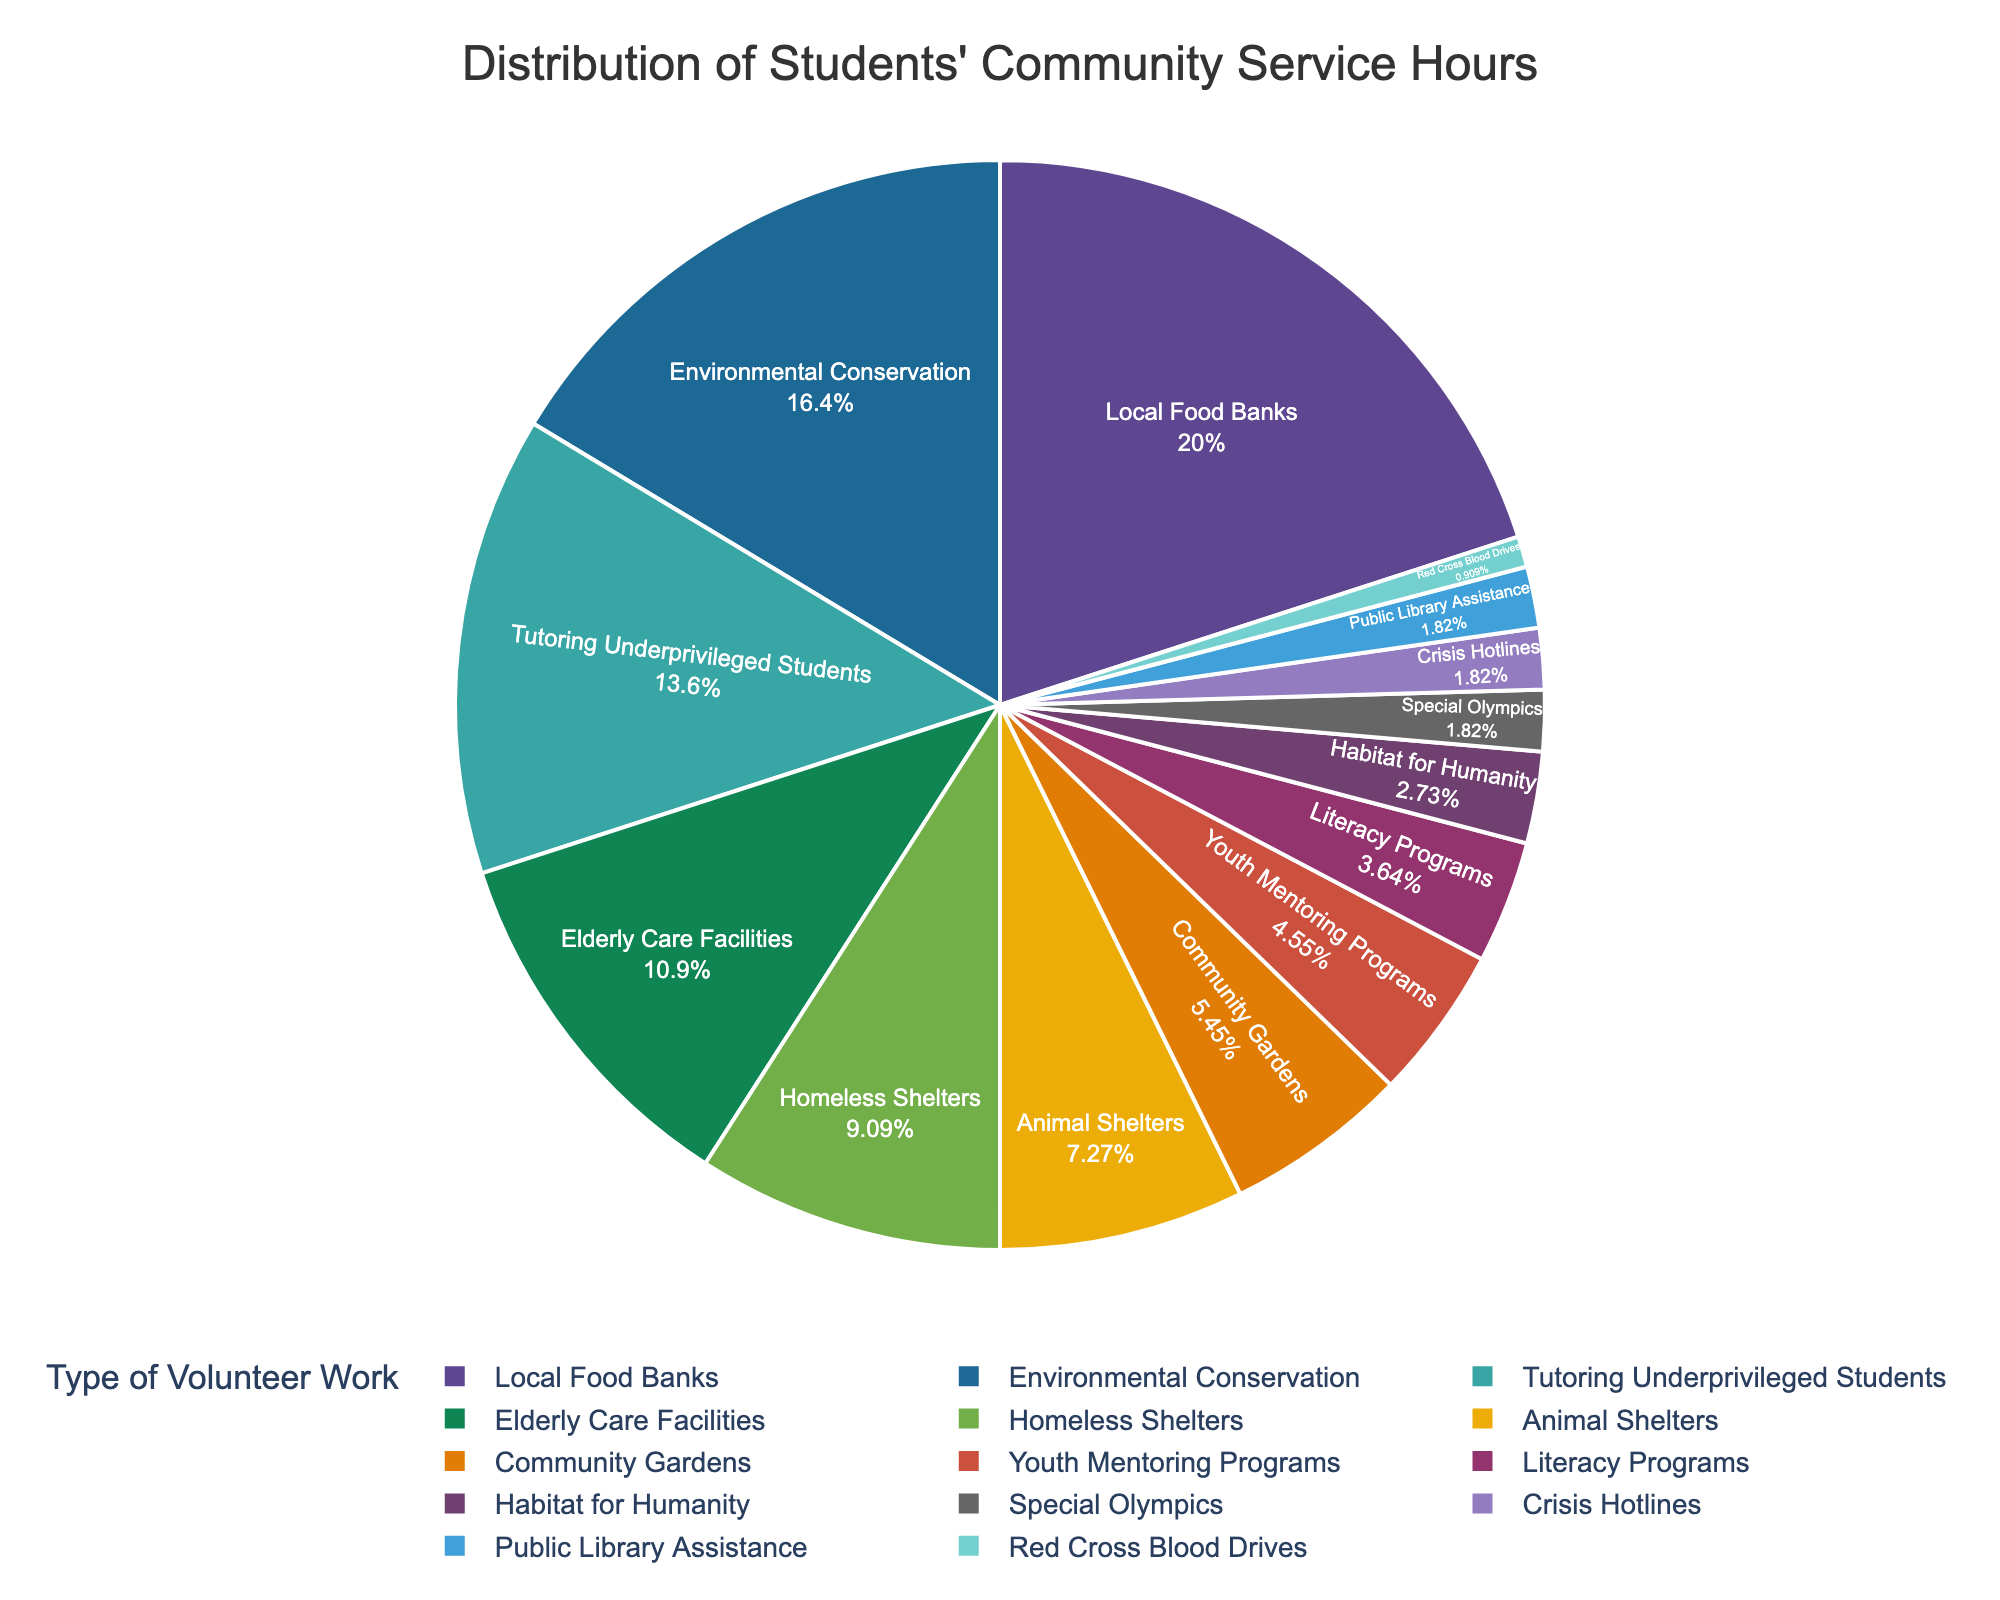Which type of volunteer work constitutes the largest percentage of students' community service hours? The slice representing "Local Food Banks" appears to be the largest one.
Answer: Local Food Banks What is the approximate percentage difference between hours spent on Environmental Conservation and Tutoring Underprivileged Students? The percentage for Environmental Conservation is 18%, and for Tutoring Underprivileged Students, it is 15%. The difference is calculated as 18% - 15%.
Answer: 3% Which three types of volunteer work are least popular among students? The smallest slices correspond to "Red Cross Blood Drives," "Crisis Hotlines," and "Special Olympics," each with 1%, 2%, and 2% respectively.
Answer: Red Cross Blood Drives, Crisis Hotlines, Special Olympics How does the time spent on Elderly Care Facilities compare to the time spent on Homeless Shelters? The chart shows that Elderly Care Facilities constitute 12%, while Homeless Shelters constitute 10%, making Elderly Care Facilities 2% more.
Answer: Elderly Care Facilities have 2% more Sum the percentages of volunteer hours for Animal Shelters and Community Gardens. According to the chart, Animal Shelters are 8% and Community Gardens are 6%. Summing them gives 8% + 6% = 14%.
Answer: 14% What is the combined percentage of youth-focused volunteer activities (Tutoring Underprivileged Students, Youth Mentoring Programs, Literacy Programs)? The percentages are Tutoring Underprivileged Students (15%), Youth Mentoring Programs (5%), and Literacy Programs (4%). Summing them gives 15% + 5% + 4%.
Answer: 24% Which type of volunteer work is represented by a purple slice in the chart? The chart likely uses a standard color scheme where "Tutoring Underprivileged Students" is not a primary color like red, blue, etc. So "Tutoring Underprivileged Students" correlated with purple.
Answer: Tutoring Underprivileged Students What percentage of students' community service hours is dedicated to both Local Food Banks and Environmental Conservation combined? The percentage for Local Food Banks is 22%, and for Environmental Conservation, it is 18%. Summing them gives 22% + 18%.
Answer: 40% How much greater is the percentage for Local Food Banks than for Community Gardens? The percentage for Local Food Banks is 22%, and for Community Gardens, it is 6%. The difference is calculated as 22% - 6%.
Answer: 16% How many volunteer work types constitute less than 5% each of the students' community service hours? The types with less than 5% are Literacy Programs (4%), Habitat for Humanity (3%), Special Olympics (2%), Crisis Hotlines (2%), Public Library Assistance (2%), and Red Cross Blood Drives (1%).
Answer: 6 